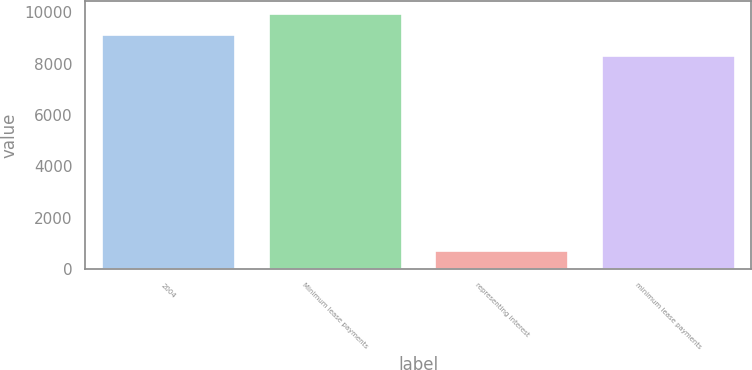Convert chart. <chart><loc_0><loc_0><loc_500><loc_500><bar_chart><fcel>2004<fcel>Minimum lease payments<fcel>representing interest<fcel>minimum lease payments<nl><fcel>9124.5<fcel>9954<fcel>705<fcel>8295<nl></chart> 